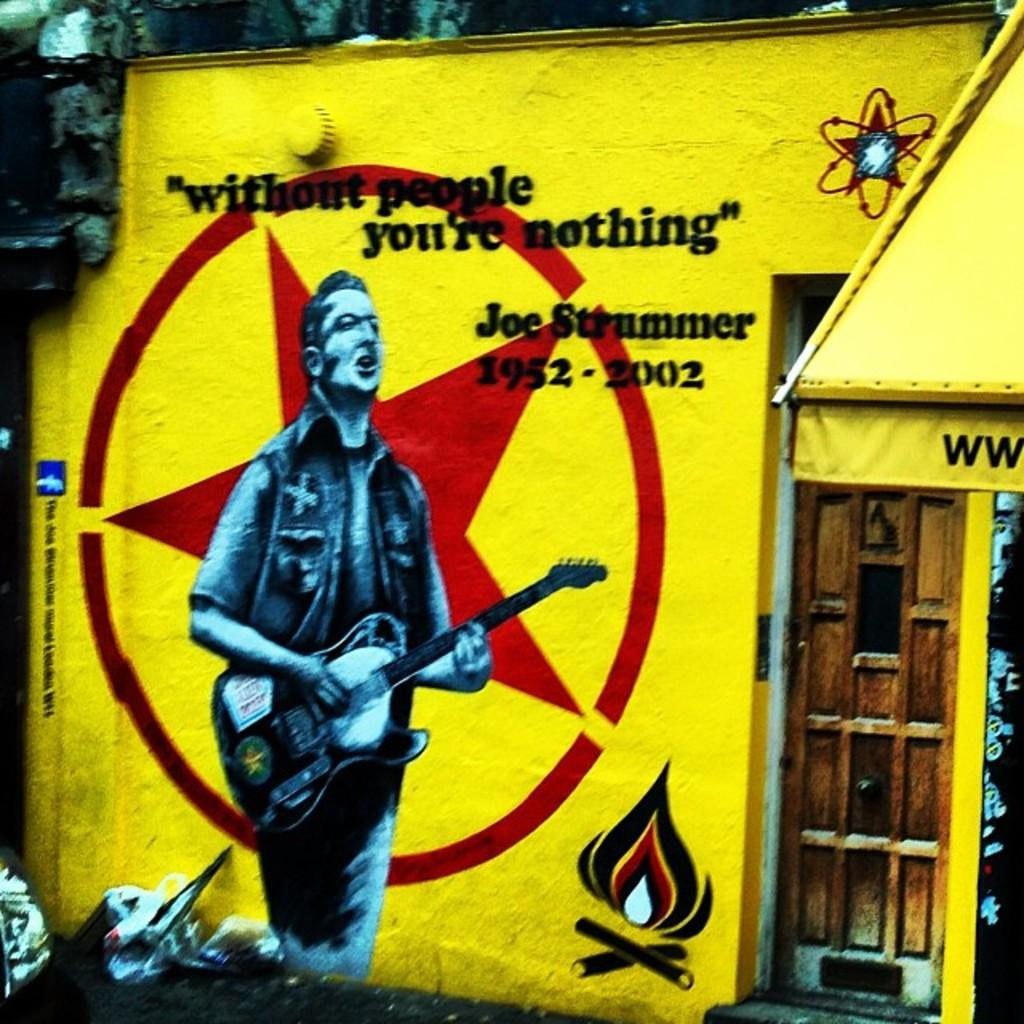<image>
Relay a brief, clear account of the picture shown. the year 2002 on the yellow flag of a person 